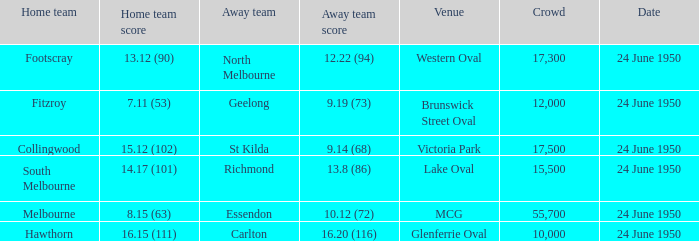Would you be able to parse every entry in this table? {'header': ['Home team', 'Home team score', 'Away team', 'Away team score', 'Venue', 'Crowd', 'Date'], 'rows': [['Footscray', '13.12 (90)', 'North Melbourne', '12.22 (94)', 'Western Oval', '17,300', '24 June 1950'], ['Fitzroy', '7.11 (53)', 'Geelong', '9.19 (73)', 'Brunswick Street Oval', '12,000', '24 June 1950'], ['Collingwood', '15.12 (102)', 'St Kilda', '9.14 (68)', 'Victoria Park', '17,500', '24 June 1950'], ['South Melbourne', '14.17 (101)', 'Richmond', '13.8 (86)', 'Lake Oval', '15,500', '24 June 1950'], ['Melbourne', '8.15 (63)', 'Essendon', '10.12 (72)', 'MCG', '55,700', '24 June 1950'], ['Hawthorn', '16.15 (111)', 'Carlton', '16.20 (116)', 'Glenferrie Oval', '10,000', '24 June 1950']]} Which team played as the host when north melbourne was the visiting team and the audience exceeded 12,000 people? Footscray. 